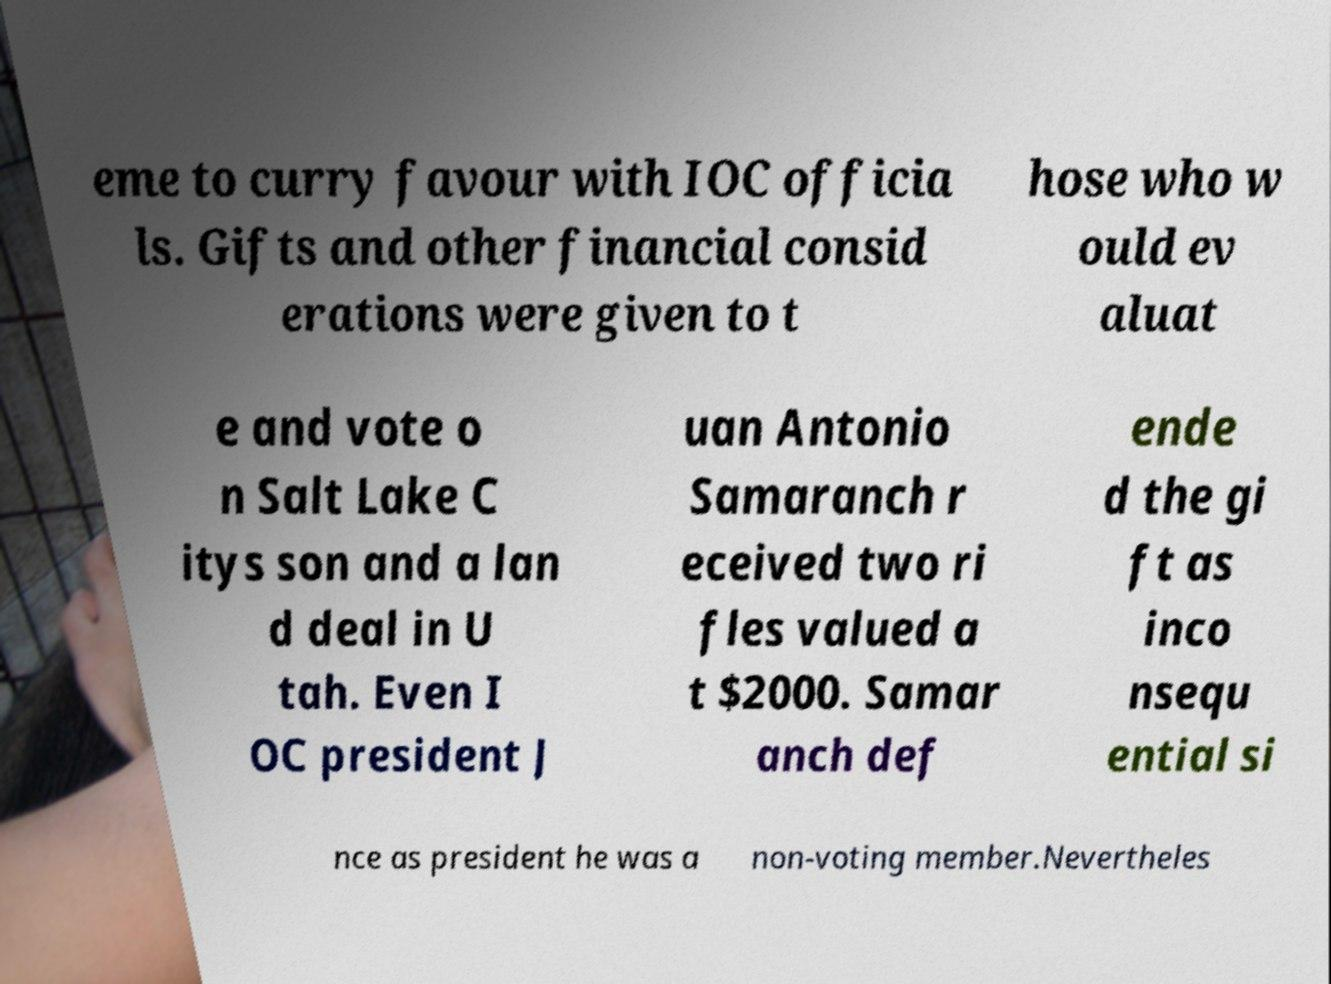Please identify and transcribe the text found in this image. eme to curry favour with IOC officia ls. Gifts and other financial consid erations were given to t hose who w ould ev aluat e and vote o n Salt Lake C itys son and a lan d deal in U tah. Even I OC president J uan Antonio Samaranch r eceived two ri fles valued a t $2000. Samar anch def ende d the gi ft as inco nsequ ential si nce as president he was a non-voting member.Nevertheles 